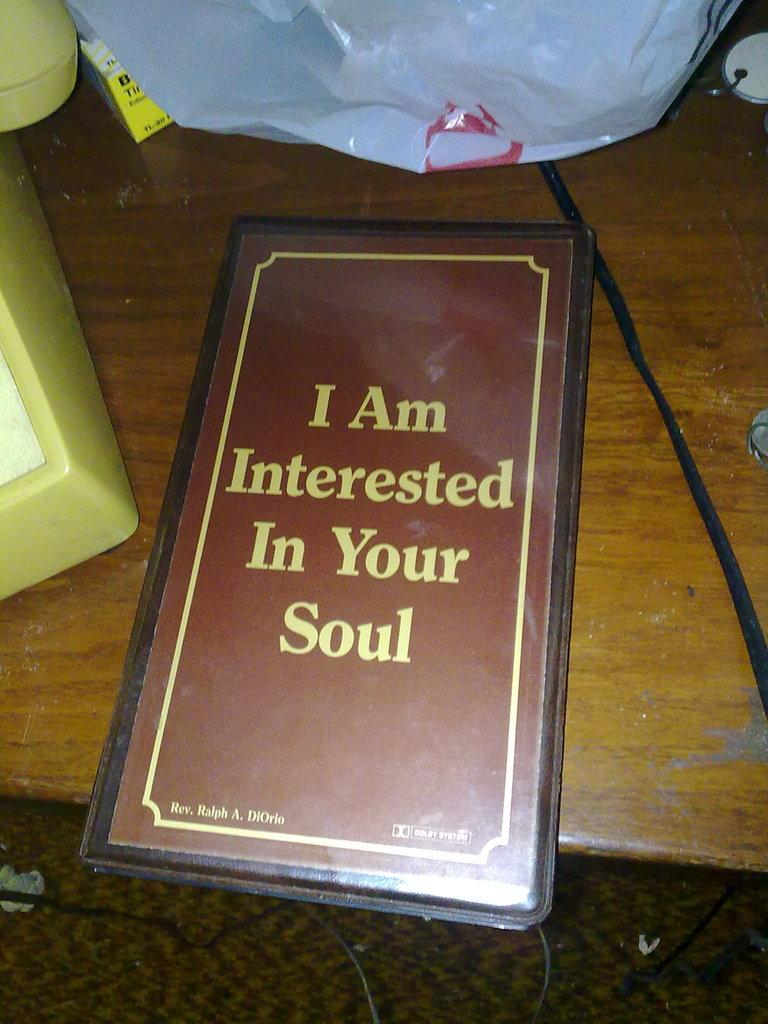<image>
Give a short and clear explanation of the subsequent image. A brown and yellow book that says I am interested in your soul on the front. 